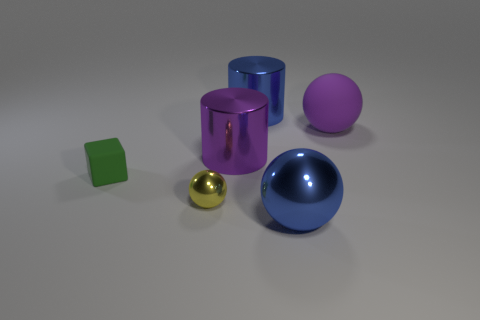There is a large blue thing behind the large rubber thing; what number of big blue metal things are on the right side of it?
Provide a short and direct response. 1. How many tiny things are the same shape as the large purple matte object?
Provide a short and direct response. 1. How many tiny matte cylinders are there?
Offer a terse response. 0. There is a rubber thing that is on the left side of the large purple rubber object; what color is it?
Keep it short and to the point. Green. There is a big ball on the right side of the big thing in front of the green matte cube; what is its color?
Make the answer very short. Purple. What color is the shiny ball that is the same size as the green matte thing?
Your answer should be very brief. Yellow. How many large objects are in front of the small yellow shiny ball and behind the small matte cube?
Your answer should be compact. 0. There is another large thing that is the same color as the big matte object; what shape is it?
Offer a very short reply. Cylinder. There is a sphere that is behind the big metallic sphere and on the right side of the tiny yellow metal ball; what is it made of?
Ensure brevity in your answer.  Rubber. Are there fewer rubber spheres that are in front of the big matte ball than large objects behind the small green rubber thing?
Offer a very short reply. Yes. 